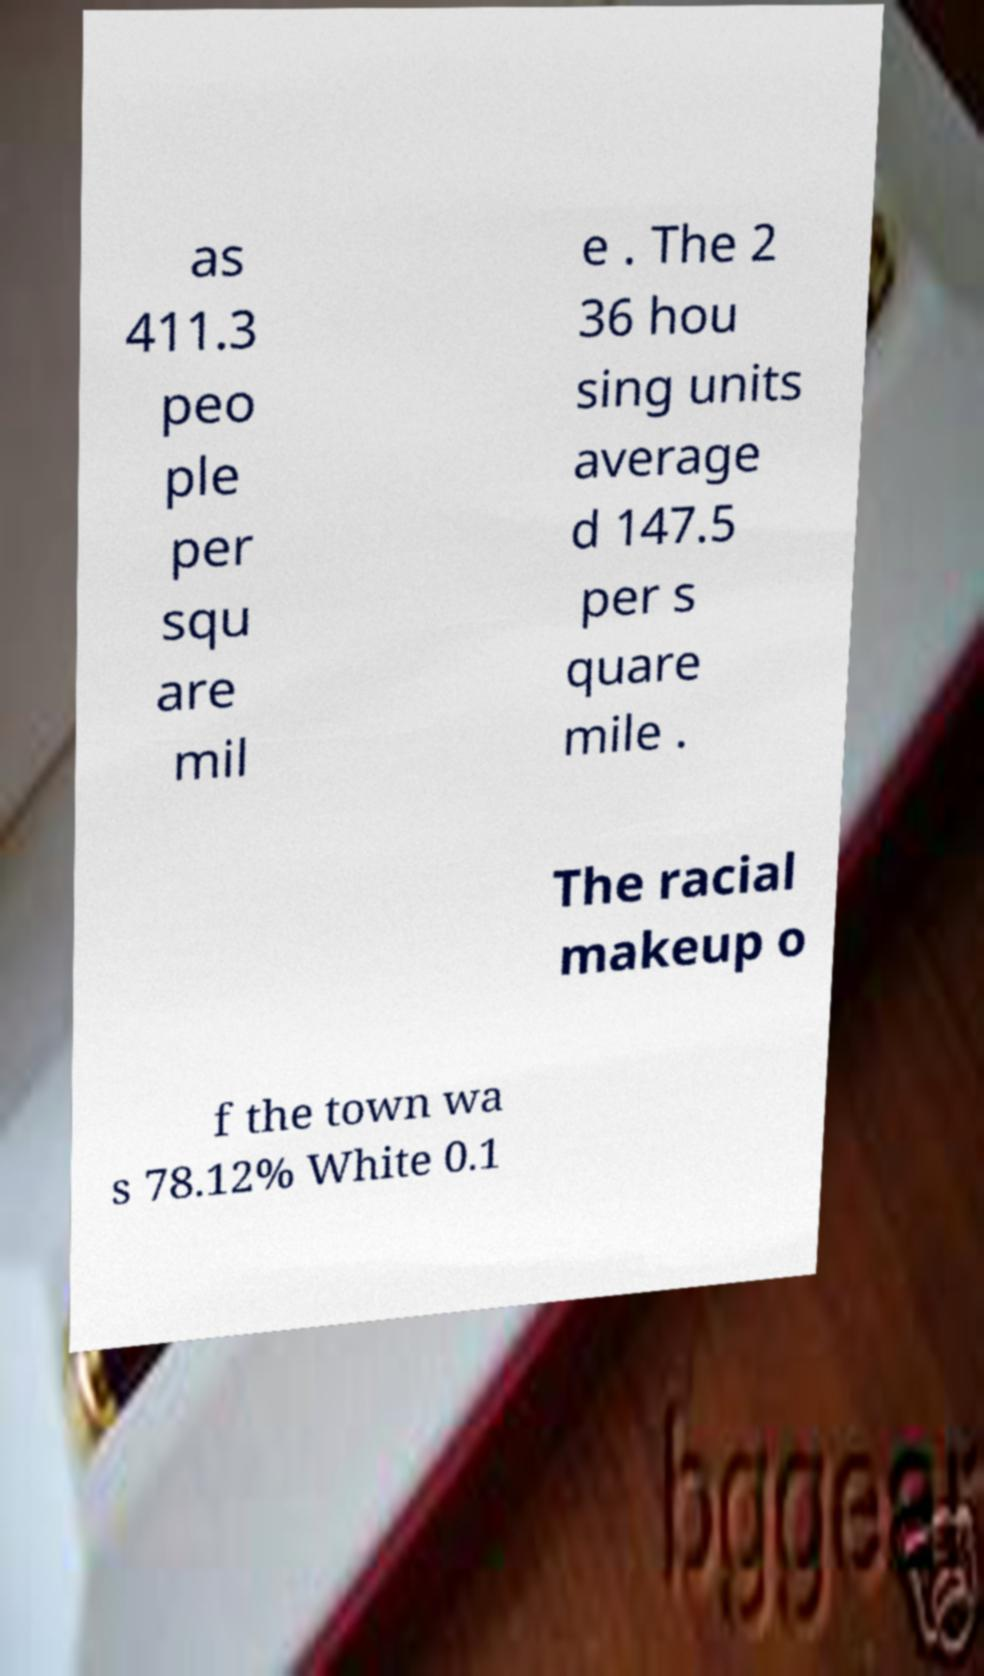Can you accurately transcribe the text from the provided image for me? as 411.3 peo ple per squ are mil e . The 2 36 hou sing units average d 147.5 per s quare mile . The racial makeup o f the town wa s 78.12% White 0.1 